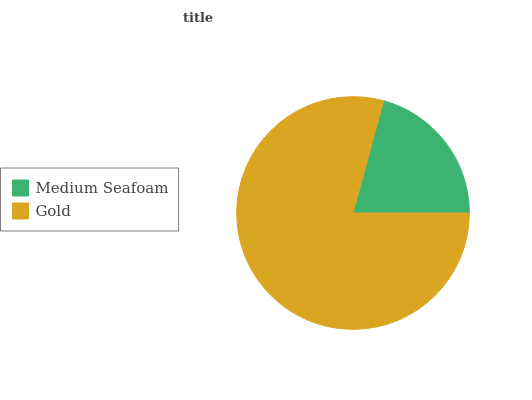Is Medium Seafoam the minimum?
Answer yes or no. Yes. Is Gold the maximum?
Answer yes or no. Yes. Is Gold the minimum?
Answer yes or no. No. Is Gold greater than Medium Seafoam?
Answer yes or no. Yes. Is Medium Seafoam less than Gold?
Answer yes or no. Yes. Is Medium Seafoam greater than Gold?
Answer yes or no. No. Is Gold less than Medium Seafoam?
Answer yes or no. No. Is Gold the high median?
Answer yes or no. Yes. Is Medium Seafoam the low median?
Answer yes or no. Yes. Is Medium Seafoam the high median?
Answer yes or no. No. Is Gold the low median?
Answer yes or no. No. 